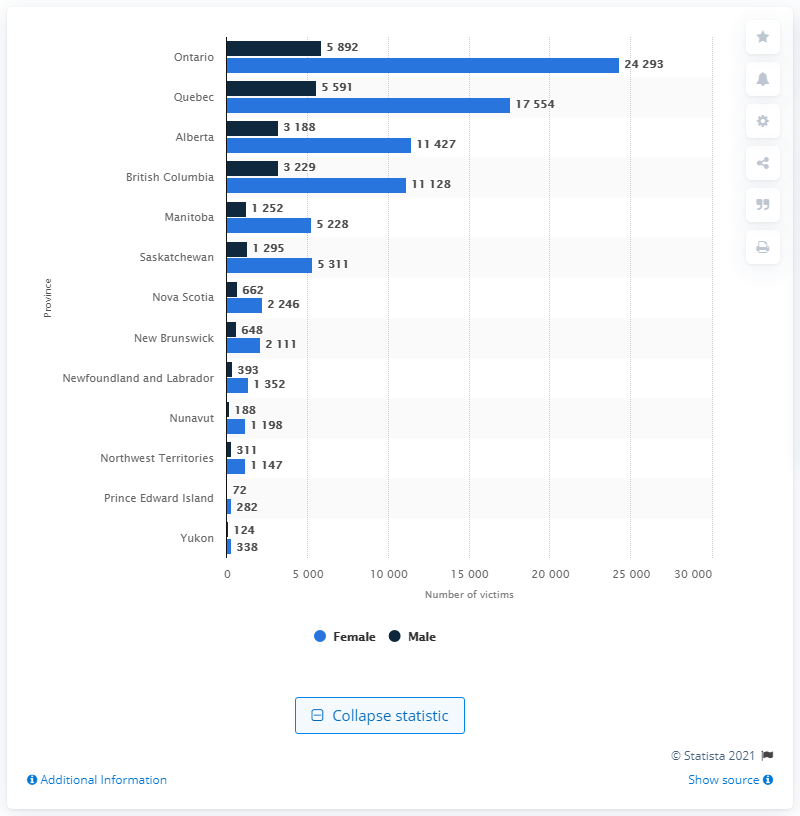Give some essential details in this illustration. In 2019, a total of 5,892 men in Ontario were victims of intimate partner violence. According to the data, Ontario has the highest number of intimate partner violence victims in Canada. 